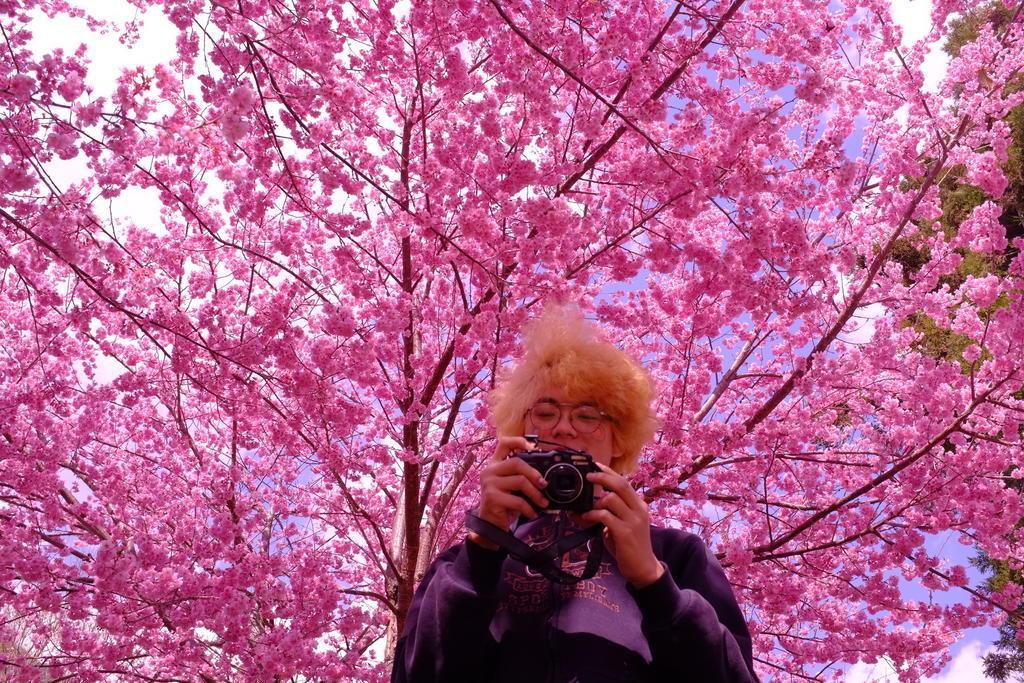In one or two sentences, can you explain what this image depicts? a person is standing holding a camera. behind her there is a pink tree and at the right corner there is a green tree. 